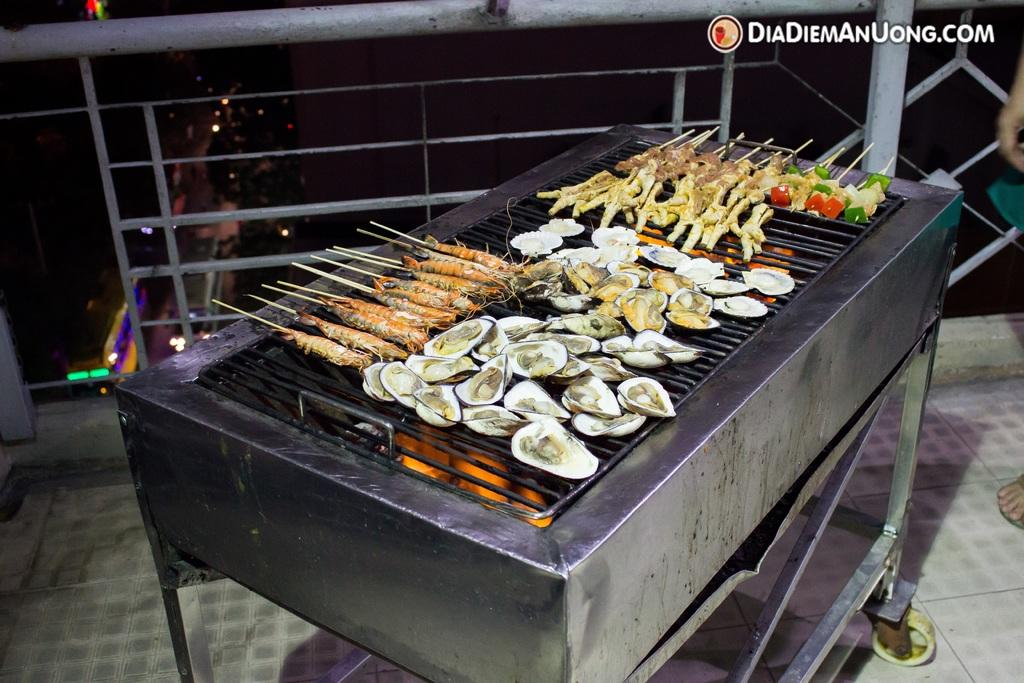<image>
Render a clear and concise summary of the photo. A grill set up on a balcony overlooking the city from DiaDiemAnUong.com 